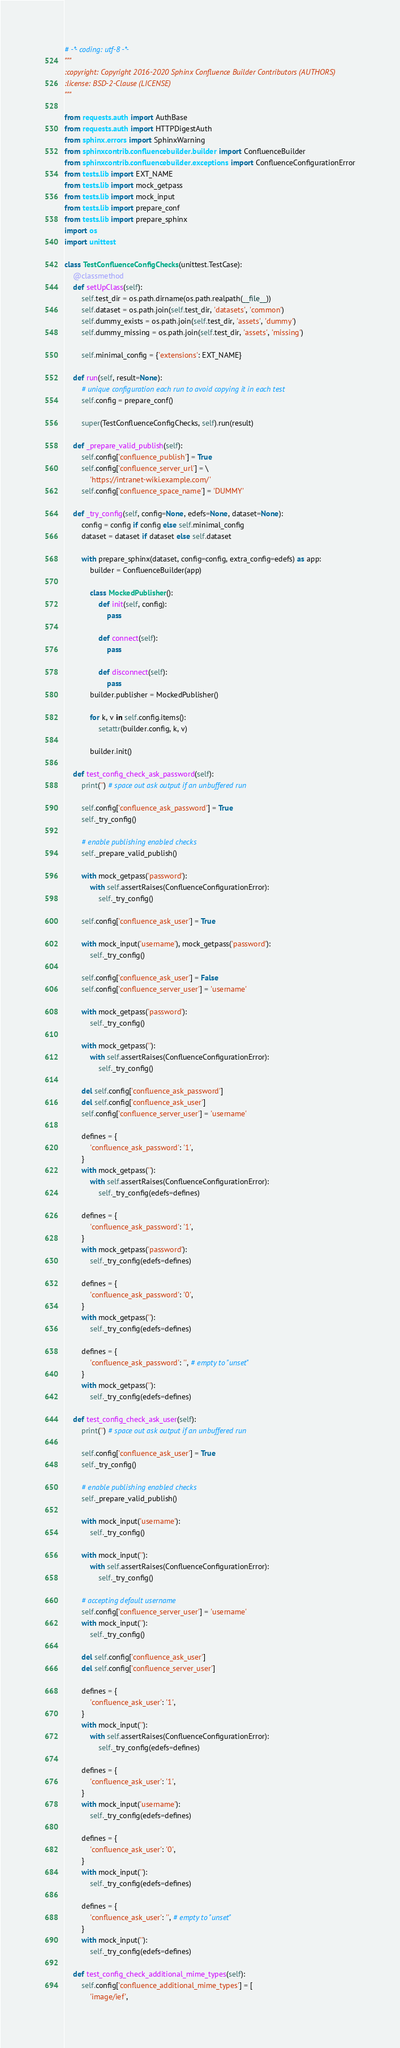<code> <loc_0><loc_0><loc_500><loc_500><_Python_># -*- coding: utf-8 -*-
"""
:copyright: Copyright 2016-2020 Sphinx Confluence Builder Contributors (AUTHORS)
:license: BSD-2-Clause (LICENSE)
"""

from requests.auth import AuthBase
from requests.auth import HTTPDigestAuth
from sphinx.errors import SphinxWarning
from sphinxcontrib.confluencebuilder.builder import ConfluenceBuilder
from sphinxcontrib.confluencebuilder.exceptions import ConfluenceConfigurationError
from tests.lib import EXT_NAME
from tests.lib import mock_getpass
from tests.lib import mock_input
from tests.lib import prepare_conf
from tests.lib import prepare_sphinx
import os
import unittest

class TestConfluenceConfigChecks(unittest.TestCase):
    @classmethod
    def setUpClass(self):
        self.test_dir = os.path.dirname(os.path.realpath(__file__))
        self.dataset = os.path.join(self.test_dir, 'datasets', 'common')
        self.dummy_exists = os.path.join(self.test_dir, 'assets', 'dummy')
        self.dummy_missing = os.path.join(self.test_dir, 'assets', 'missing')

        self.minimal_config = {'extensions': EXT_NAME}

    def run(self, result=None):
        # unique configuration each run to avoid copying it in each test
        self.config = prepare_conf()

        super(TestConfluenceConfigChecks, self).run(result)

    def _prepare_valid_publish(self):
        self.config['confluence_publish'] = True
        self.config['confluence_server_url'] = \
            'https://intranet-wiki.example.com/'
        self.config['confluence_space_name'] = 'DUMMY'

    def _try_config(self, config=None, edefs=None, dataset=None):
        config = config if config else self.minimal_config
        dataset = dataset if dataset else self.dataset

        with prepare_sphinx(dataset, config=config, extra_config=edefs) as app:
            builder = ConfluenceBuilder(app)

            class MockedPublisher():
                def init(self, config):
                    pass

                def connect(self):
                    pass

                def disconnect(self):
                    pass
            builder.publisher = MockedPublisher()

            for k, v in self.config.items():
                setattr(builder.config, k, v)

            builder.init()

    def test_config_check_ask_password(self):
        print('') # space out ask output if an unbuffered run

        self.config['confluence_ask_password'] = True
        self._try_config()

        # enable publishing enabled checks
        self._prepare_valid_publish()

        with mock_getpass('password'):
            with self.assertRaises(ConfluenceConfigurationError):
                self._try_config()

        self.config['confluence_ask_user'] = True

        with mock_input('username'), mock_getpass('password'):
            self._try_config()

        self.config['confluence_ask_user'] = False
        self.config['confluence_server_user'] = 'username'

        with mock_getpass('password'):
            self._try_config()

        with mock_getpass(''):
            with self.assertRaises(ConfluenceConfigurationError):
                self._try_config()

        del self.config['confluence_ask_password']
        del self.config['confluence_ask_user']
        self.config['confluence_server_user'] = 'username'

        defines = {
            'confluence_ask_password': '1',
        }
        with mock_getpass(''):
            with self.assertRaises(ConfluenceConfigurationError):
                self._try_config(edefs=defines)

        defines = {
            'confluence_ask_password': '1',
        }
        with mock_getpass('password'):
            self._try_config(edefs=defines)

        defines = {
            'confluence_ask_password': '0',
        }
        with mock_getpass(''):
            self._try_config(edefs=defines)

        defines = {
            'confluence_ask_password': '', # empty to "unset"
        }
        with mock_getpass(''):
            self._try_config(edefs=defines)

    def test_config_check_ask_user(self):
        print('') # space out ask output if an unbuffered run

        self.config['confluence_ask_user'] = True
        self._try_config()

        # enable publishing enabled checks
        self._prepare_valid_publish()

        with mock_input('username'):
            self._try_config()

        with mock_input(''):
            with self.assertRaises(ConfluenceConfigurationError):
                self._try_config()

        # accepting default username
        self.config['confluence_server_user'] = 'username'
        with mock_input(''):
            self._try_config()

        del self.config['confluence_ask_user']
        del self.config['confluence_server_user']

        defines = {
            'confluence_ask_user': '1',
        }
        with mock_input(''):
            with self.assertRaises(ConfluenceConfigurationError):
                self._try_config(edefs=defines)

        defines = {
            'confluence_ask_user': '1',
        }
        with mock_input('username'):
            self._try_config(edefs=defines)

        defines = {
            'confluence_ask_user': '0',
        }
        with mock_input(''):
            self._try_config(edefs=defines)

        defines = {
            'confluence_ask_user': '', # empty to "unset"
        }
        with mock_input(''):
            self._try_config(edefs=defines)

    def test_config_check_additional_mime_types(self):
        self.config['confluence_additional_mime_types'] = [
            'image/ief',</code> 